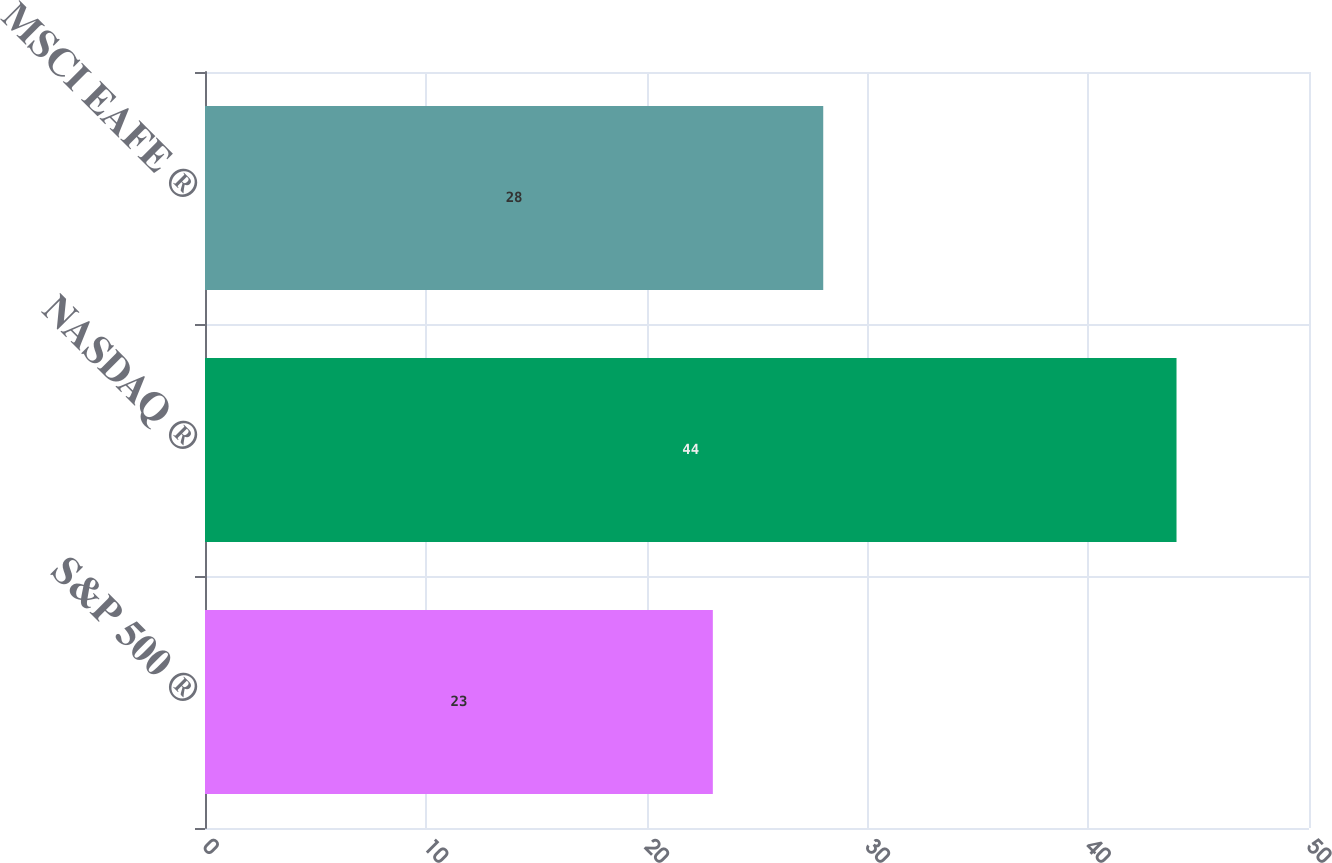Convert chart to OTSL. <chart><loc_0><loc_0><loc_500><loc_500><bar_chart><fcel>S&P 500 ®<fcel>NASDAQ ®<fcel>MSCI EAFE ®<nl><fcel>23<fcel>44<fcel>28<nl></chart> 